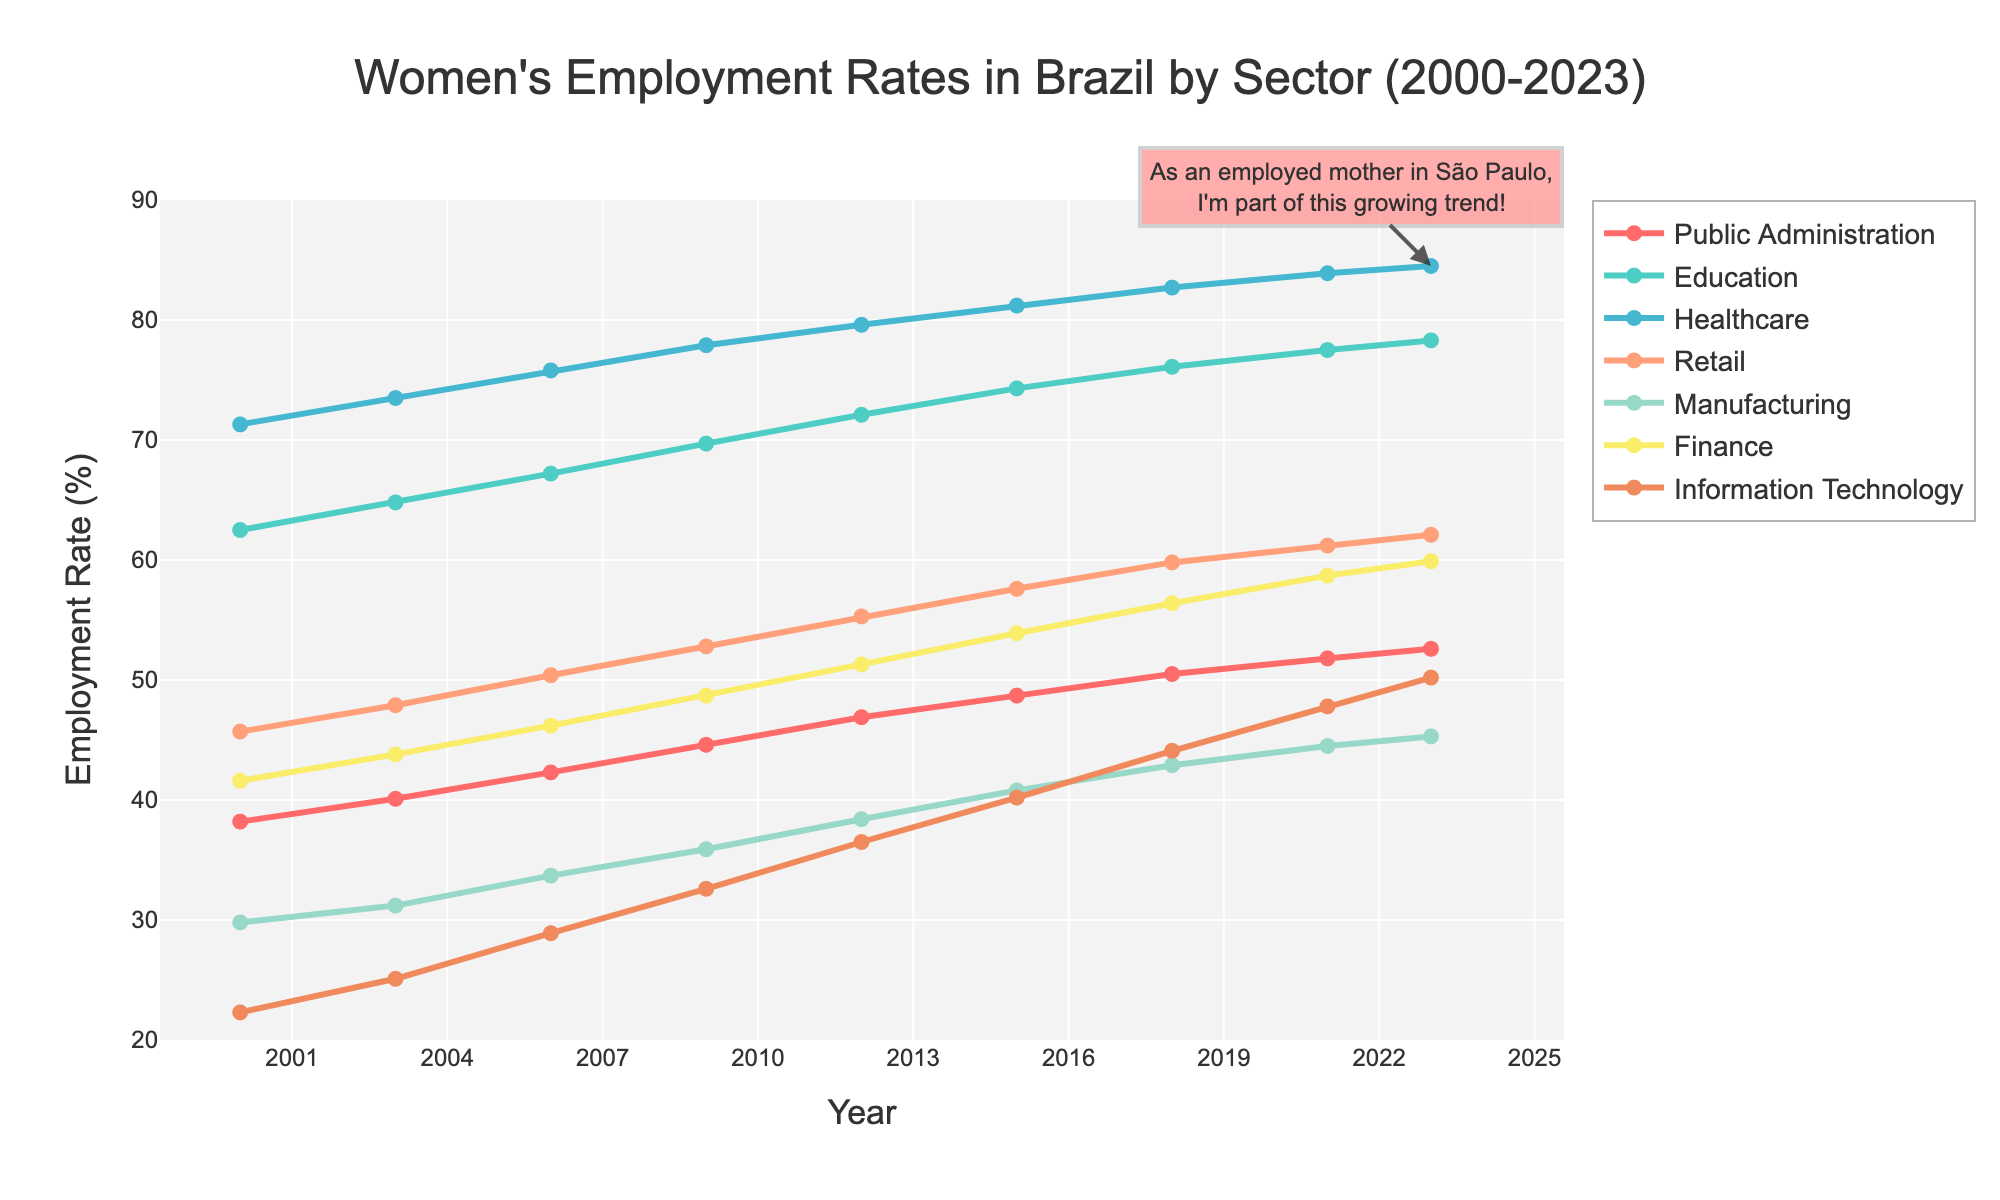What is the employment rate trend in the Healthcare sector from 2000 to 2023? The Healthcare sector starts at 71.3% in 2000 and increases steadily over time, reaching 84.5% in 2023, indicating a rising trend.
Answer: Rising trend Which sector has the highest employment rate in 2023? In 2023, the Healthcare sector has the highest employment rate at 84.5%, which is visually the tallest line endpoint on the graph.
Answer: Healthcare Compare the employment rates in the Finance sector in 2000 and 2023. What is the difference? The employment rate in the Finance sector was 41.6% in 2000 and 59.9% in 2023. The difference is 59.9% - 41.6% = 18.3%.
Answer: 18.3% Which sector shows the least increase in women's employment rates from 2000 to 2023? The Information Technology sector starts at 22.3% in 2000 and ends at 50.2% in 2023, giving an increase of 50.2% - 22.3% = 27.9%, the smallest increase compared to other sectors.
Answer: Information Technology In which year did the Retail sector surpass the 50% employment rate? The Retail sector surpasses the 50% employment rate in the year 2006, reaching 50.4%.
Answer: 2006 Which sector had a higher employment rate in 2015, Manufacturing or Public Administration? In 2015, Manufacturing had an employment rate of 40.8%, while Public Administration had 48.7%, making Public Administration higher.
Answer: Public Administration Compare the employment rate trend of the Education sector to the Finance sector from 2000 to 2023. The Education sector shows a consistent increase from 62.5% to 78.3% while the Finance sector rises from 41.6% to 59.9%. Both show an upward trend, but Education has higher rates throughout.
Answer: Education is consistently higher Between 2000 and 2023, during which periods did the Retail sector have an increase in employment rate every consecutive year? The Retail sector shows continuous increases between 2000 to 2003, 2003 to 2006, 2006 to 2009, 2009 to 2012, 2012 to 2015, and 2015 to 2018, and 2021 to 2023.
Answer: Multiple periods What is the overall increase in employment rate in the Public Administration sector from 2000 to 2023? The Public Administration sector increased from 38.2% in 2000 to 52.6% in 2023. The overall increase is 52.6% - 38.2% = 14.4%.
Answer: 14.4% 